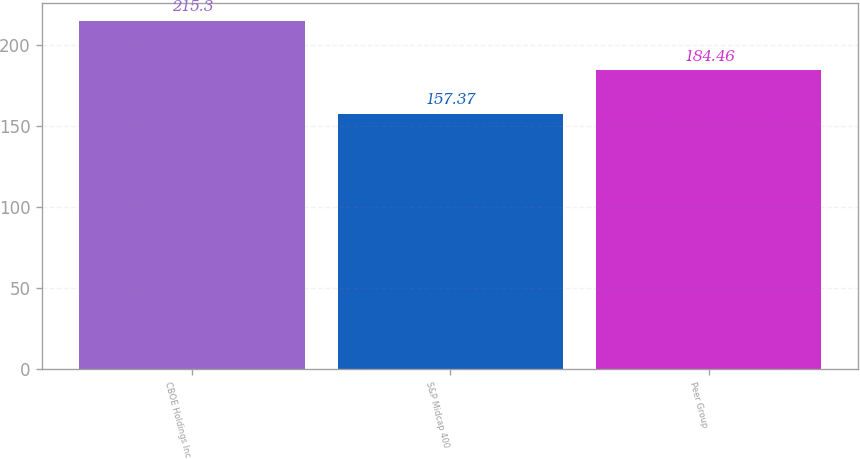Convert chart to OTSL. <chart><loc_0><loc_0><loc_500><loc_500><bar_chart><fcel>CBOE Holdings Inc<fcel>S&P Midcap 400<fcel>Peer Group<nl><fcel>215.3<fcel>157.37<fcel>184.46<nl></chart> 